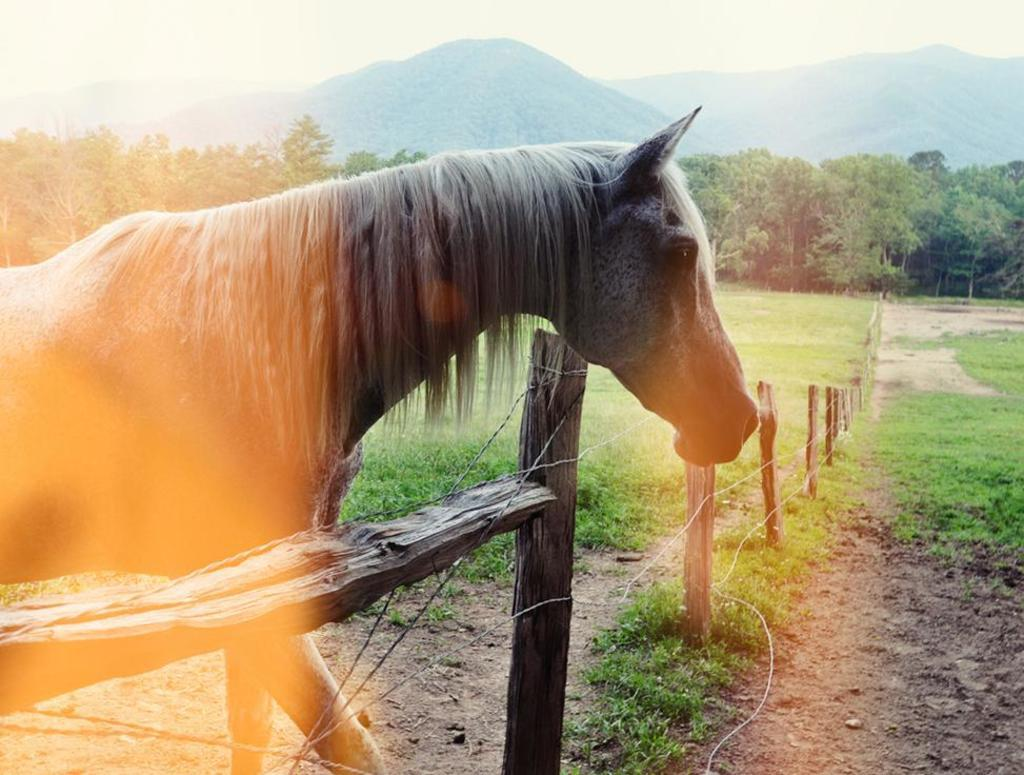What animal can be seen in the foreground of the image? There is a horse in the foreground of the image. What type of vegetation is present in the foreground of the image? There is grass in the foreground of the image. What type of barrier is visible in the foreground of the image? There is a fence in the foreground of the image. What type of natural features can be seen in the background of the image? There are trees, mountains, and the sky visible in the background of the image. Where was the image taken? The image was taken in a zoo. What type of doctor can be seen treating the horse in the image? There is no doctor present in the image, and the horse is not being treated. What type of structure is visible in the background of the image? There is no specific structure visible in the background of the image; only trees, mountains, and the sky are present. 